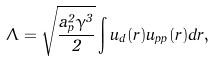<formula> <loc_0><loc_0><loc_500><loc_500>\Lambda = \sqrt { \frac { a _ { p } ^ { 2 } \gamma ^ { 3 } } { 2 } } \int u _ { d } ( r ) u _ { p p } ( r ) d r ,</formula> 